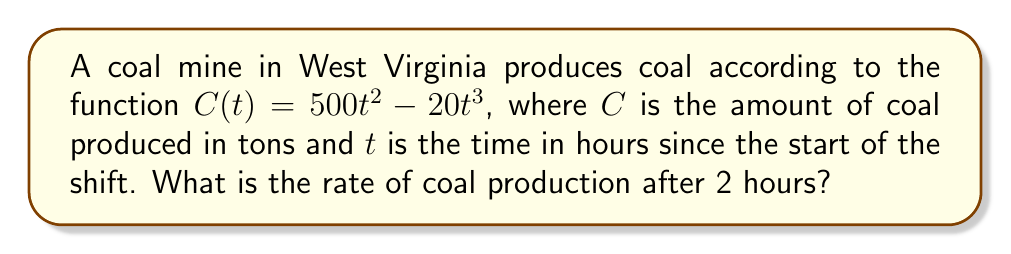Show me your answer to this math problem. To solve this problem, we need to follow these steps:

1. Understand that the rate of production is the derivative of the production function.
2. Find the derivative of $C(t)$ with respect to $t$.
3. Evaluate the derivative at $t = 2$.

Step 1: The rate of production is given by $\frac{dC}{dt}$.

Step 2: Let's find the derivative of $C(t)$:
$$\begin{align}
C(t) &= 500t^2 - 20t^3 \\
\frac{dC}{dt} &= 1000t - 60t^2
\end{align}$$

We used the power rule of differentiation:
- For $500t^2$, the derivative is $500 \cdot 2t = 1000t$
- For $-20t^3$, the derivative is $-20 \cdot 3t^2 = -60t^2$

Step 3: Now, let's evaluate $\frac{dC}{dt}$ at $t = 2$:
$$\begin{align}
\frac{dC}{dt}\bigg|_{t=2} &= 1000(2) - 60(2)^2 \\
&= 2000 - 60(4) \\
&= 2000 - 240 \\
&= 1760
\end{align}$$

Therefore, after 2 hours, the rate of coal production is 1760 tons per hour.
Answer: 1760 tons/hour 